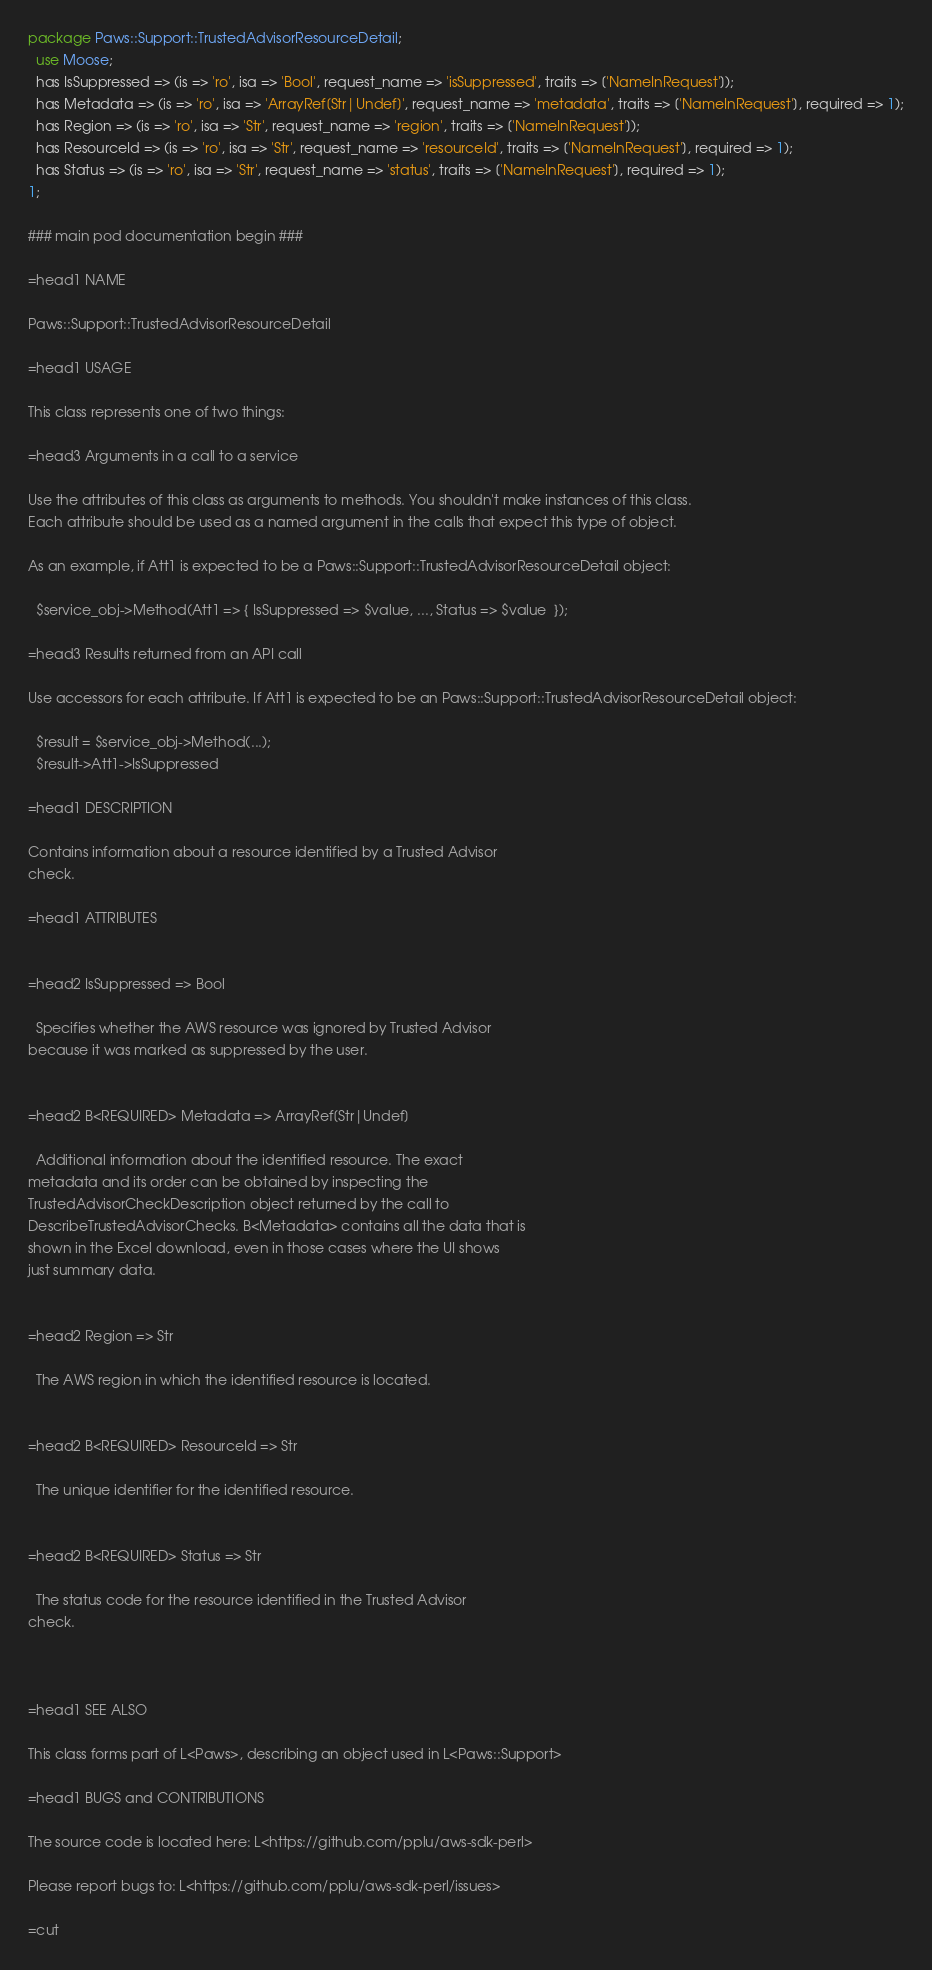<code> <loc_0><loc_0><loc_500><loc_500><_Perl_>package Paws::Support::TrustedAdvisorResourceDetail;
  use Moose;
  has IsSuppressed => (is => 'ro', isa => 'Bool', request_name => 'isSuppressed', traits => ['NameInRequest']);
  has Metadata => (is => 'ro', isa => 'ArrayRef[Str|Undef]', request_name => 'metadata', traits => ['NameInRequest'], required => 1);
  has Region => (is => 'ro', isa => 'Str', request_name => 'region', traits => ['NameInRequest']);
  has ResourceId => (is => 'ro', isa => 'Str', request_name => 'resourceId', traits => ['NameInRequest'], required => 1);
  has Status => (is => 'ro', isa => 'Str', request_name => 'status', traits => ['NameInRequest'], required => 1);
1;

### main pod documentation begin ###

=head1 NAME

Paws::Support::TrustedAdvisorResourceDetail

=head1 USAGE

This class represents one of two things:

=head3 Arguments in a call to a service

Use the attributes of this class as arguments to methods. You shouldn't make instances of this class. 
Each attribute should be used as a named argument in the calls that expect this type of object.

As an example, if Att1 is expected to be a Paws::Support::TrustedAdvisorResourceDetail object:

  $service_obj->Method(Att1 => { IsSuppressed => $value, ..., Status => $value  });

=head3 Results returned from an API call

Use accessors for each attribute. If Att1 is expected to be an Paws::Support::TrustedAdvisorResourceDetail object:

  $result = $service_obj->Method(...);
  $result->Att1->IsSuppressed

=head1 DESCRIPTION

Contains information about a resource identified by a Trusted Advisor
check.

=head1 ATTRIBUTES


=head2 IsSuppressed => Bool

  Specifies whether the AWS resource was ignored by Trusted Advisor
because it was marked as suppressed by the user.


=head2 B<REQUIRED> Metadata => ArrayRef[Str|Undef]

  Additional information about the identified resource. The exact
metadata and its order can be obtained by inspecting the
TrustedAdvisorCheckDescription object returned by the call to
DescribeTrustedAdvisorChecks. B<Metadata> contains all the data that is
shown in the Excel download, even in those cases where the UI shows
just summary data.


=head2 Region => Str

  The AWS region in which the identified resource is located.


=head2 B<REQUIRED> ResourceId => Str

  The unique identifier for the identified resource.


=head2 B<REQUIRED> Status => Str

  The status code for the resource identified in the Trusted Advisor
check.



=head1 SEE ALSO

This class forms part of L<Paws>, describing an object used in L<Paws::Support>

=head1 BUGS and CONTRIBUTIONS

The source code is located here: L<https://github.com/pplu/aws-sdk-perl>

Please report bugs to: L<https://github.com/pplu/aws-sdk-perl/issues>

=cut

</code> 